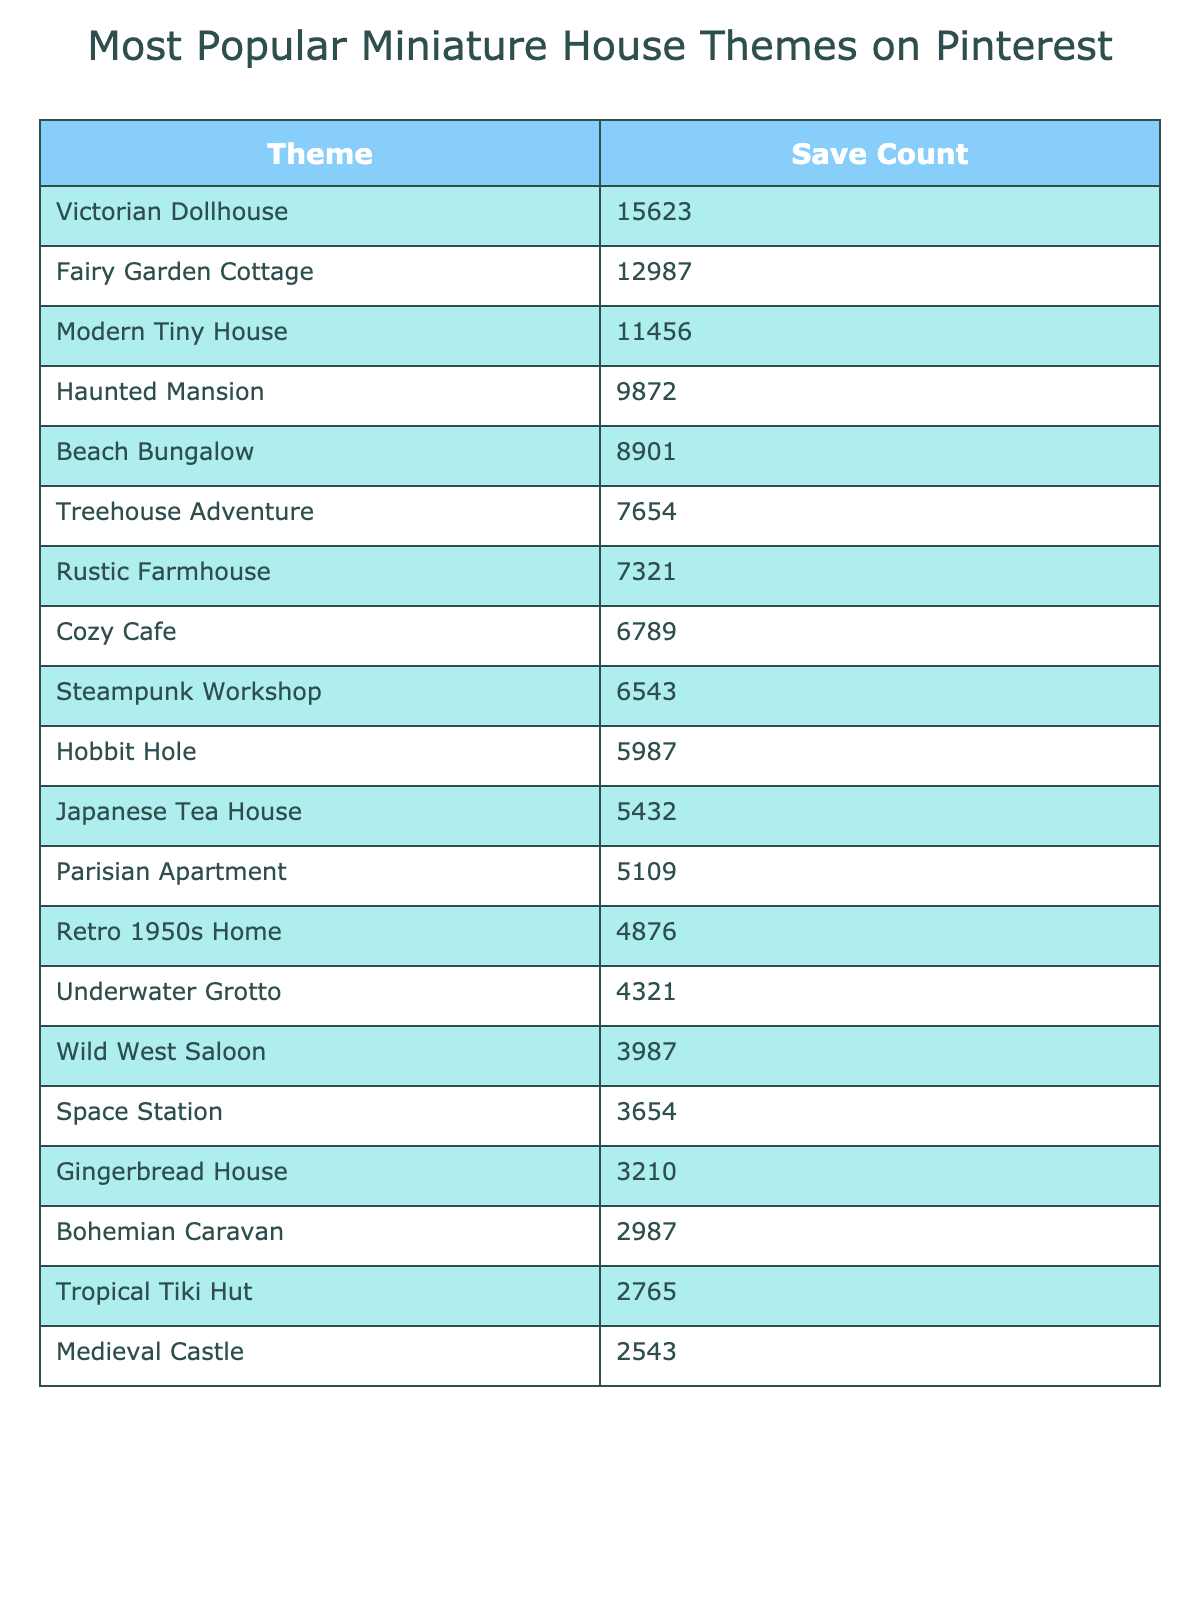What is the theme with the highest number of saves? Looking at the table, "Victorian Dollhouse" has the highest SaveCount of 15623.
Answer: Victorian Dollhouse How many saves does the Modern Tiny House have? The table shows that "Modern Tiny House" has 11456 saves.
Answer: 11456 What is the total number of saves for the top three themes? Adding the saves of the top three themes: 15623 (Victorian Dollhouse) + 12987 (Fairy Garden Cottage) + 11456 (Modern Tiny House) equals 40066.
Answer: 40066 Which theme has less than 5000 saves? By reviewing the table, "Gingerbread House" with 3210 saves is the only theme with less than 5000 saves.
Answer: Gingerbread House Is the Beach Bungalow more popular than the Treehouse Adventure? Comparing their SaveCounts, Beach Bungalow has 8901 saves while Treehouse Adventure has 7654, confirming that Beach Bungalow is more popular.
Answer: Yes What is the difference in saves between the Haunted Mansion and the Rustic Farmhouse? The Haunted Mansion has 9872 saves, and the Rustic Farmhouse has 7321 saves. The difference is 9872 - 7321 = 2551.
Answer: 2551 If we consider the top four themes, what percentage of total saves do they represent? First, sum the top four themes: 15623 + 12987 + 11456 + 9872 = 50000. Then, find the total saves for all themes, which is 15623 + 12987 + 11456 + 9872 + 8901 + 7654 + 7321 + 6789 + 6543 + 5987 + 5432 + 5109 + 4876 + 4321 + 3987 + 3654 + 3210 + 2987 + 2765 + 2543 = 102262. Now calculate (50000 / 102262) * 100 = approximately 48.9%.
Answer: Approximately 48.9% Which theme has the lowest SaveCount? The table indicates that "Medieval Castle" has the lowest SaveCount with 2543 saves.
Answer: Medieval Castle Are there more themes with saves above 7000 or below 7000? Counting the themes, there are 8 themes with more than 7000 saves, and 12 themes below 7000. Therefore, there are more below 7000.
Answer: Below 7000 Which two themes have the closest number of saves? Checking the saves, "Hobbit Hole" has 5987 and "Japanese Tea House" has 5432. The difference is 5987 - 5432 = 555, making them the closest with these counts.
Answer: Hobbit Hole and Japanese Tea House 